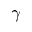Convert formula to latex. <formula><loc_0><loc_0><loc_500><loc_500>\gamma</formula> 